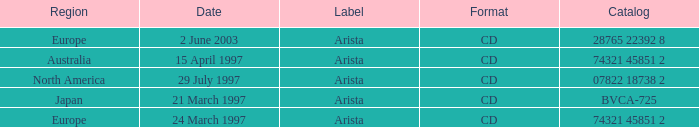What's the Date with the Region of Europe and has a Catalog of 28765 22392 8? 2 June 2003. 